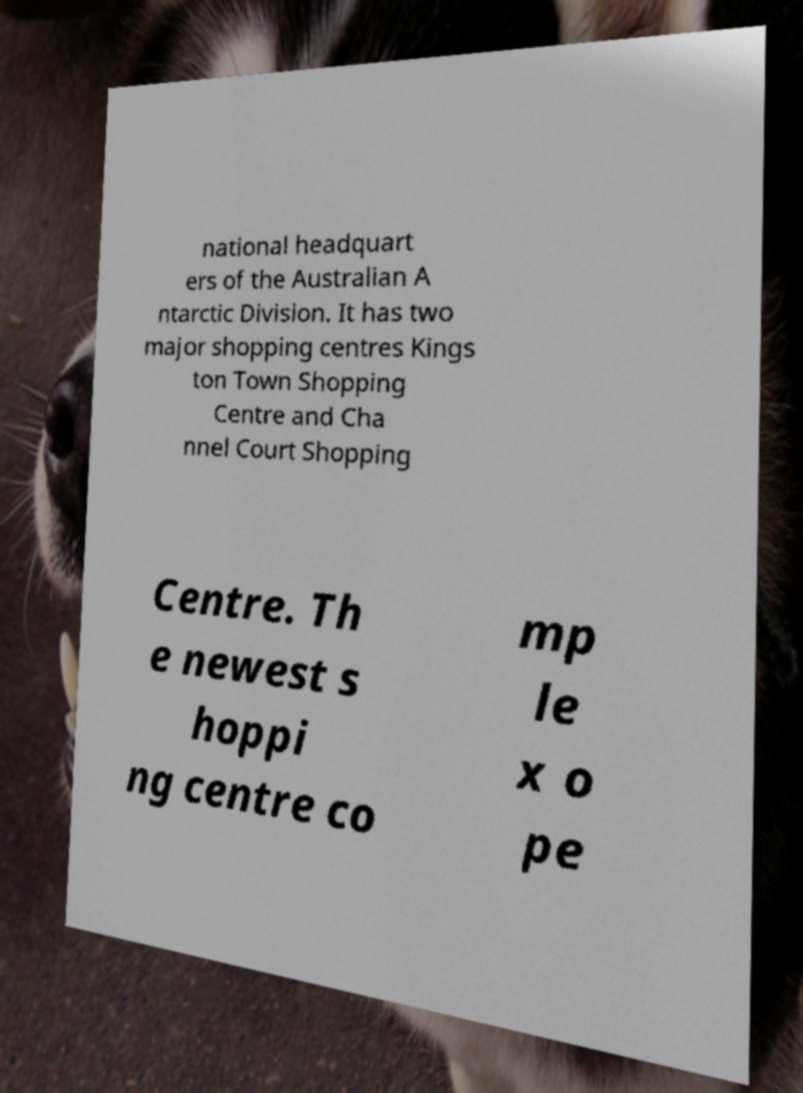Could you assist in decoding the text presented in this image and type it out clearly? national headquart ers of the Australian A ntarctic Division. It has two major shopping centres Kings ton Town Shopping Centre and Cha nnel Court Shopping Centre. Th e newest s hoppi ng centre co mp le x o pe 